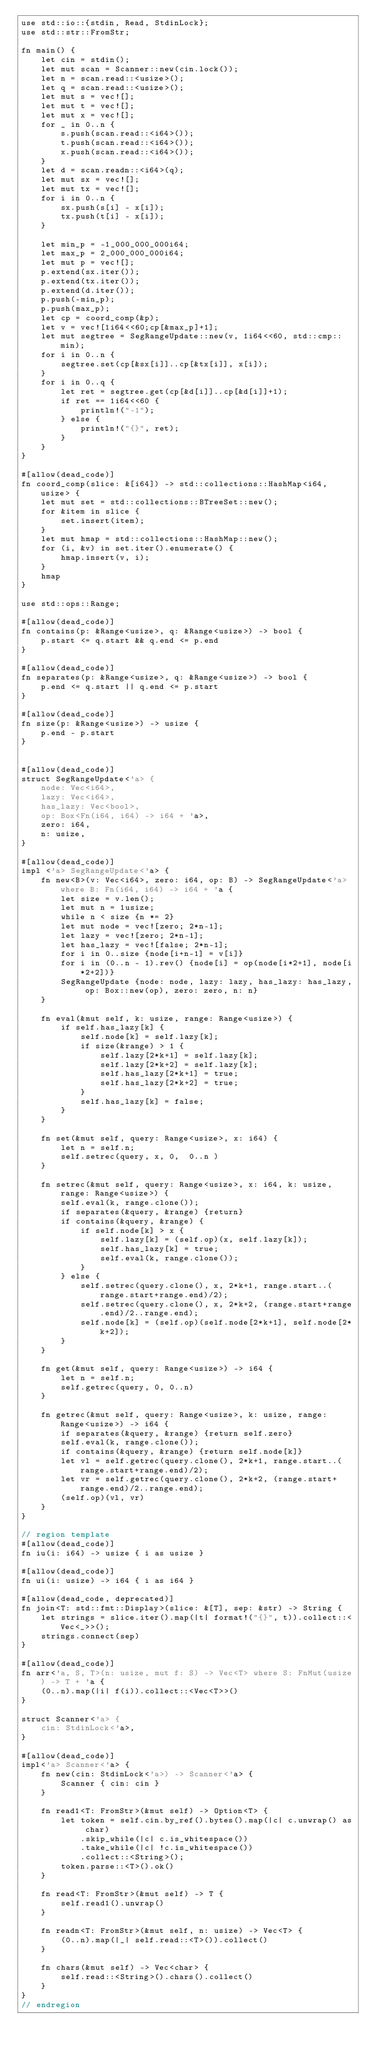Convert code to text. <code><loc_0><loc_0><loc_500><loc_500><_Rust_>use std::io::{stdin, Read, StdinLock};
use std::str::FromStr;

fn main() {
    let cin = stdin();
    let mut scan = Scanner::new(cin.lock());
    let n = scan.read::<usize>();
    let q = scan.read::<usize>();
    let mut s = vec![];
    let mut t = vec![];
    let mut x = vec![];
    for _ in 0..n {
        s.push(scan.read::<i64>());
        t.push(scan.read::<i64>());
        x.push(scan.read::<i64>());
    }
    let d = scan.readn::<i64>(q);
    let mut sx = vec![];
    let mut tx = vec![];
    for i in 0..n {
        sx.push(s[i] - x[i]);
        tx.push(t[i] - x[i]);
    }

    let min_p = -1_000_000_000i64;
    let max_p = 2_000_000_000i64;
    let mut p = vec![];
    p.extend(sx.iter());
    p.extend(tx.iter());
    p.extend(d.iter());
    p.push(-min_p);
    p.push(max_p);
    let cp = coord_comp(&p);
    let v = vec![1i64<<60;cp[&max_p]+1];
    let mut segtree = SegRangeUpdate::new(v, 1i64<<60, std::cmp::min);
    for i in 0..n {
        segtree.set(cp[&sx[i]]..cp[&tx[i]], x[i]);
    }
    for i in 0..q {
        let ret = segtree.get(cp[&d[i]]..cp[&d[i]]+1);
        if ret == 1i64<<60 {
            println!("-1");
        } else {
            println!("{}", ret);
        }
    }
}

#[allow(dead_code)]
fn coord_comp(slice: &[i64]) -> std::collections::HashMap<i64, usize> {
    let mut set = std::collections::BTreeSet::new();
    for &item in slice {
        set.insert(item);
    }
    let mut hmap = std::collections::HashMap::new();
    for (i, &v) in set.iter().enumerate() {
        hmap.insert(v, i);
    }
    hmap
}

use std::ops::Range;

#[allow(dead_code)]
fn contains(p: &Range<usize>, q: &Range<usize>) -> bool {
    p.start <= q.start && q.end <= p.end
}

#[allow(dead_code)]
fn separates(p: &Range<usize>, q: &Range<usize>) -> bool {
    p.end <= q.start || q.end <= p.start
}

#[allow(dead_code)]
fn size(p: &Range<usize>) -> usize {
    p.end - p.start
}


#[allow(dead_code)]
struct SegRangeUpdate<'a> {
    node: Vec<i64>,
    lazy: Vec<i64>,
    has_lazy: Vec<bool>,
    op: Box<Fn(i64, i64) -> i64 + 'a>,
    zero: i64,
    n: usize,
}

#[allow(dead_code)]
impl <'a> SegRangeUpdate<'a> {
    fn new<B>(v: Vec<i64>, zero: i64, op: B) -> SegRangeUpdate<'a> where B: Fn(i64, i64) -> i64 + 'a {
        let size = v.len();
        let mut n = 1usize;
        while n < size {n *= 2}
        let mut node = vec![zero; 2*n-1];
        let lazy = vec![zero; 2*n-1];
        let has_lazy = vec![false; 2*n-1];
        for i in 0..size {node[i+n-1] = v[i]}
        for i in (0..n - 1).rev() {node[i] = op(node[i*2+1], node[i*2+2])}
        SegRangeUpdate {node: node, lazy: lazy, has_lazy: has_lazy, op: Box::new(op), zero: zero, n: n}
    }

    fn eval(&mut self, k: usize, range: Range<usize>) {
        if self.has_lazy[k] {
            self.node[k] = self.lazy[k];
            if size(&range) > 1 {
                self.lazy[2*k+1] = self.lazy[k];
                self.lazy[2*k+2] = self.lazy[k];
                self.has_lazy[2*k+1] = true;
                self.has_lazy[2*k+2] = true;
            }
            self.has_lazy[k] = false;
        }
    }

    fn set(&mut self, query: Range<usize>, x: i64) {
        let n = self.n;
        self.setrec(query, x, 0,  0..n )
    }

    fn setrec(&mut self, query: Range<usize>, x: i64, k: usize, range: Range<usize>) {
        self.eval(k, range.clone());
        if separates(&query, &range) {return}
        if contains(&query, &range) {
            if self.node[k] > x {
                self.lazy[k] = (self.op)(x, self.lazy[k]);
                self.has_lazy[k] = true;
                self.eval(k, range.clone());
            }
        } else {
            self.setrec(query.clone(), x, 2*k+1, range.start..(range.start+range.end)/2);
            self.setrec(query.clone(), x, 2*k+2, (range.start+range.end)/2..range.end);
            self.node[k] = (self.op)(self.node[2*k+1], self.node[2*k+2]);
        }
    }

    fn get(&mut self, query: Range<usize>) -> i64 {
        let n = self.n;
        self.getrec(query, 0, 0..n)
    }

    fn getrec(&mut self, query: Range<usize>, k: usize, range: Range<usize>) -> i64 {
        if separates(&query, &range) {return self.zero}
        self.eval(k, range.clone());
        if contains(&query, &range) {return self.node[k]}
        let vl = self.getrec(query.clone(), 2*k+1, range.start..(range.start+range.end)/2);
        let vr = self.getrec(query.clone(), 2*k+2, (range.start+range.end)/2..range.end);
        (self.op)(vl, vr)
    }
}

// region template
#[allow(dead_code)]
fn iu(i: i64) -> usize { i as usize }

#[allow(dead_code)]
fn ui(i: usize) -> i64 { i as i64 }

#[allow(dead_code, deprecated)]
fn join<T: std::fmt::Display>(slice: &[T], sep: &str) -> String {
    let strings = slice.iter().map(|t| format!("{}", t)).collect::<Vec<_>>();
    strings.connect(sep)
}

#[allow(dead_code)]
fn arr<'a, S, T>(n: usize, mut f: S) -> Vec<T> where S: FnMut(usize) -> T + 'a {
    (0..n).map(|i| f(i)).collect::<Vec<T>>()
}

struct Scanner<'a> {
    cin: StdinLock<'a>,
}

#[allow(dead_code)]
impl<'a> Scanner<'a> {
    fn new(cin: StdinLock<'a>) -> Scanner<'a> {
        Scanner { cin: cin }
    }

    fn read1<T: FromStr>(&mut self) -> Option<T> {
        let token = self.cin.by_ref().bytes().map(|c| c.unwrap() as char)
            .skip_while(|c| c.is_whitespace())
            .take_while(|c| !c.is_whitespace())
            .collect::<String>();
        token.parse::<T>().ok()
    }

    fn read<T: FromStr>(&mut self) -> T {
        self.read1().unwrap()
    }

    fn readn<T: FromStr>(&mut self, n: usize) -> Vec<T> {
        (0..n).map(|_| self.read::<T>()).collect()
    }

    fn chars(&mut self) -> Vec<char> {
        self.read::<String>().chars().collect()
    }
}
// endregion</code> 